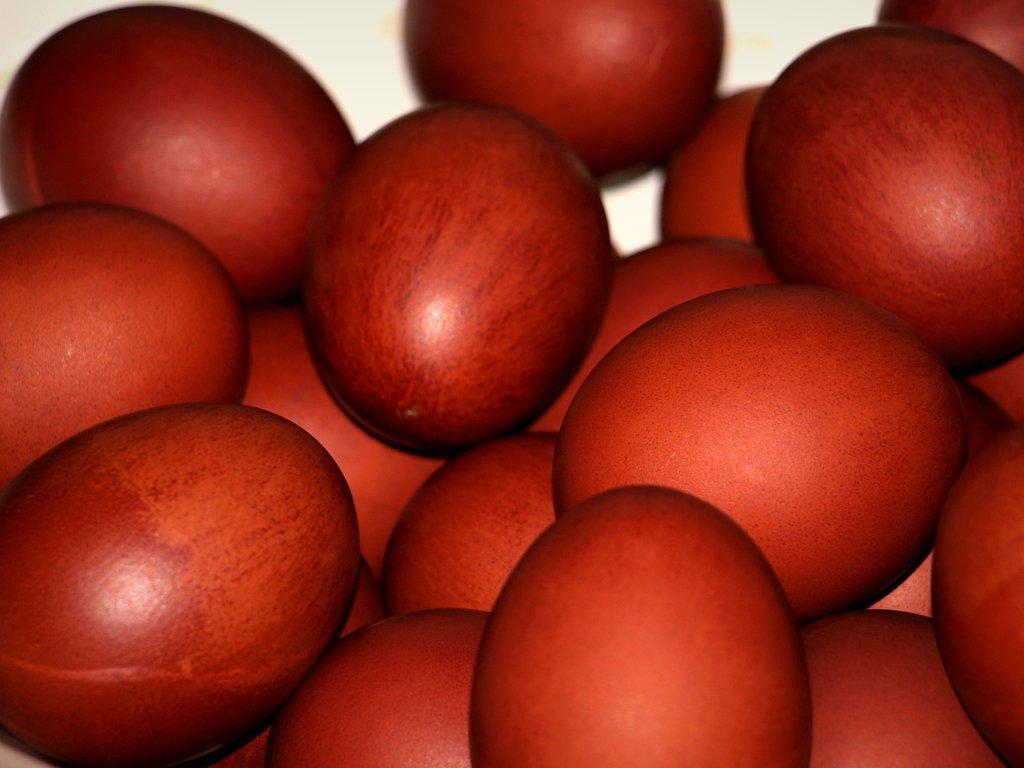Please provide a concise description of this image. In the image we can see some red color objects. 